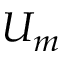<formula> <loc_0><loc_0><loc_500><loc_500>U _ { m }</formula> 